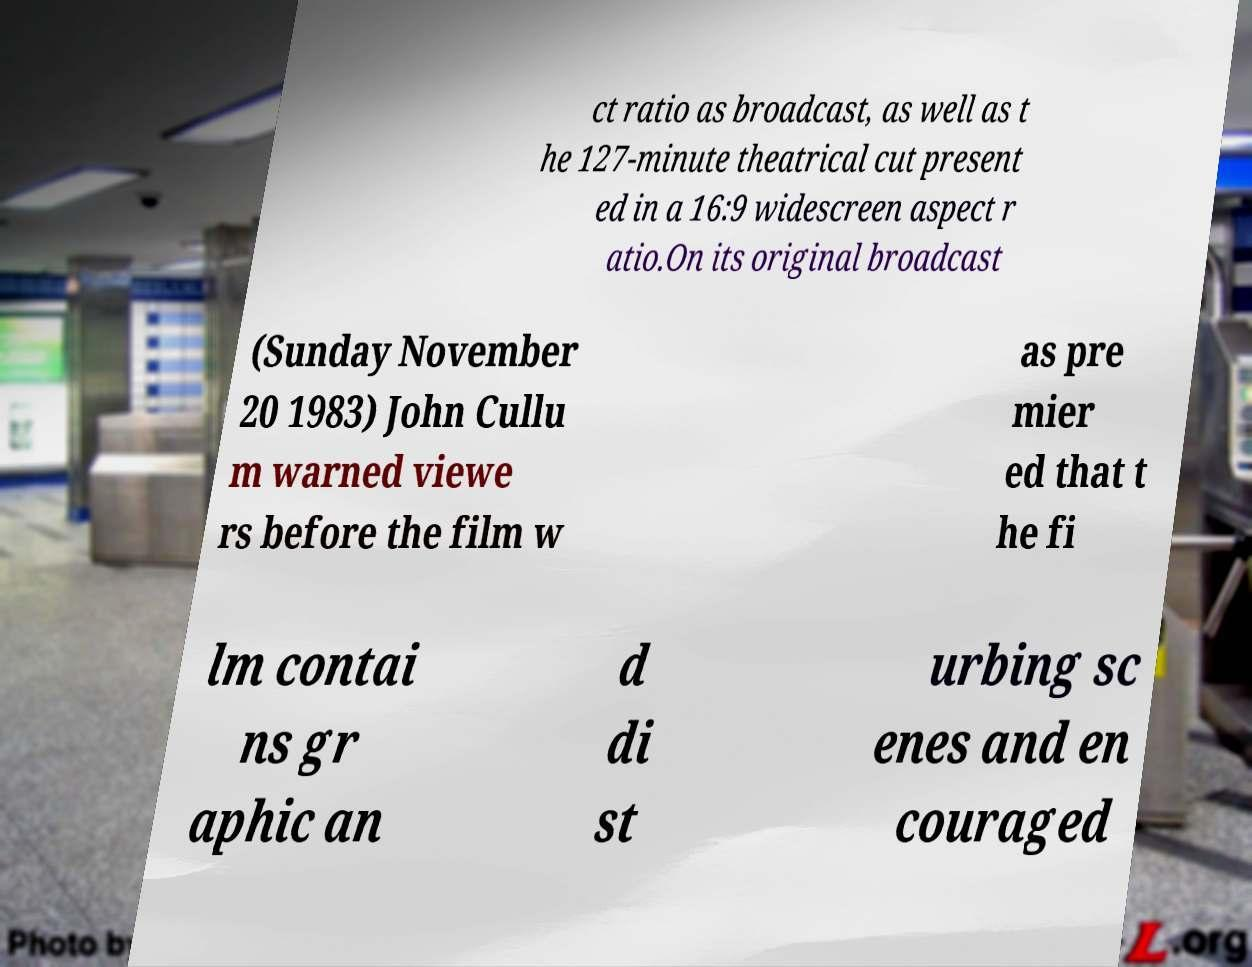I need the written content from this picture converted into text. Can you do that? ct ratio as broadcast, as well as t he 127-minute theatrical cut present ed in a 16:9 widescreen aspect r atio.On its original broadcast (Sunday November 20 1983) John Cullu m warned viewe rs before the film w as pre mier ed that t he fi lm contai ns gr aphic an d di st urbing sc enes and en couraged 